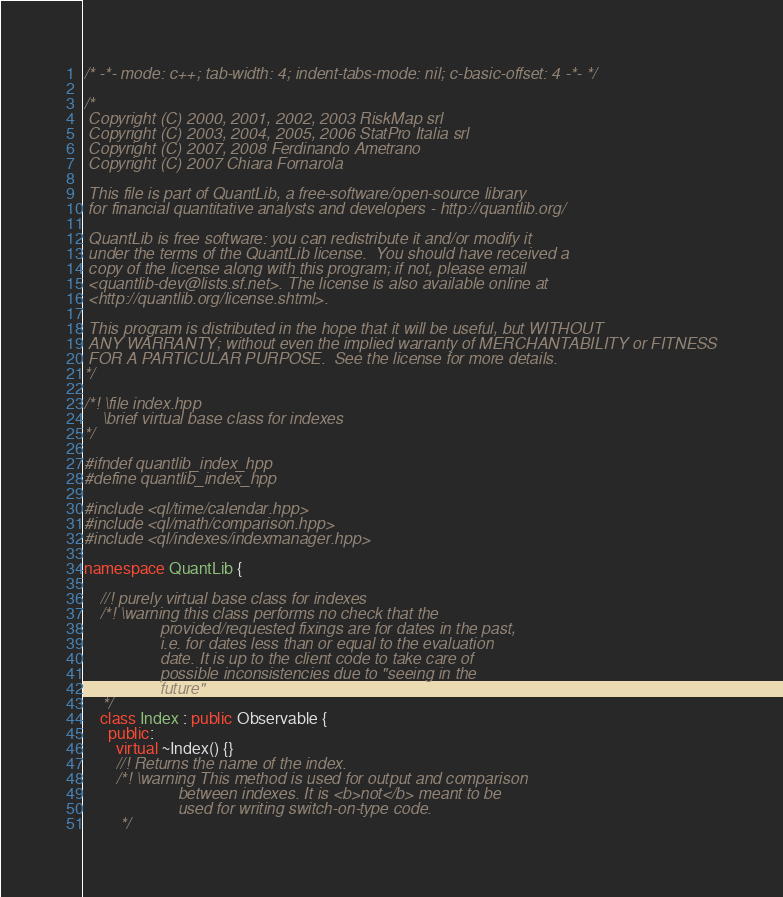Convert code to text. <code><loc_0><loc_0><loc_500><loc_500><_C++_>/* -*- mode: c++; tab-width: 4; indent-tabs-mode: nil; c-basic-offset: 4 -*- */

/*
 Copyright (C) 2000, 2001, 2002, 2003 RiskMap srl
 Copyright (C) 2003, 2004, 2005, 2006 StatPro Italia srl
 Copyright (C) 2007, 2008 Ferdinando Ametrano
 Copyright (C) 2007 Chiara Fornarola

 This file is part of QuantLib, a free-software/open-source library
 for financial quantitative analysts and developers - http://quantlib.org/

 QuantLib is free software: you can redistribute it and/or modify it
 under the terms of the QuantLib license.  You should have received a
 copy of the license along with this program; if not, please email
 <quantlib-dev@lists.sf.net>. The license is also available online at
 <http://quantlib.org/license.shtml>.

 This program is distributed in the hope that it will be useful, but WITHOUT
 ANY WARRANTY; without even the implied warranty of MERCHANTABILITY or FITNESS
 FOR A PARTICULAR PURPOSE.  See the license for more details.
*/

/*! \file index.hpp
    \brief virtual base class for indexes
*/

#ifndef quantlib_index_hpp
#define quantlib_index_hpp

#include <ql/time/calendar.hpp>
#include <ql/math/comparison.hpp>
#include <ql/indexes/indexmanager.hpp>

namespace QuantLib {

    //! purely virtual base class for indexes
    /*! \warning this class performs no check that the
                 provided/requested fixings are for dates in the past,
                 i.e. for dates less than or equal to the evaluation
                 date. It is up to the client code to take care of
                 possible inconsistencies due to "seeing in the
                 future"
    */
    class Index : public Observable {
      public:
        virtual ~Index() {}
        //! Returns the name of the index.
        /*! \warning This method is used for output and comparison
                     between indexes. It is <b>not</b> meant to be
                     used for writing switch-on-type code.
        */</code> 